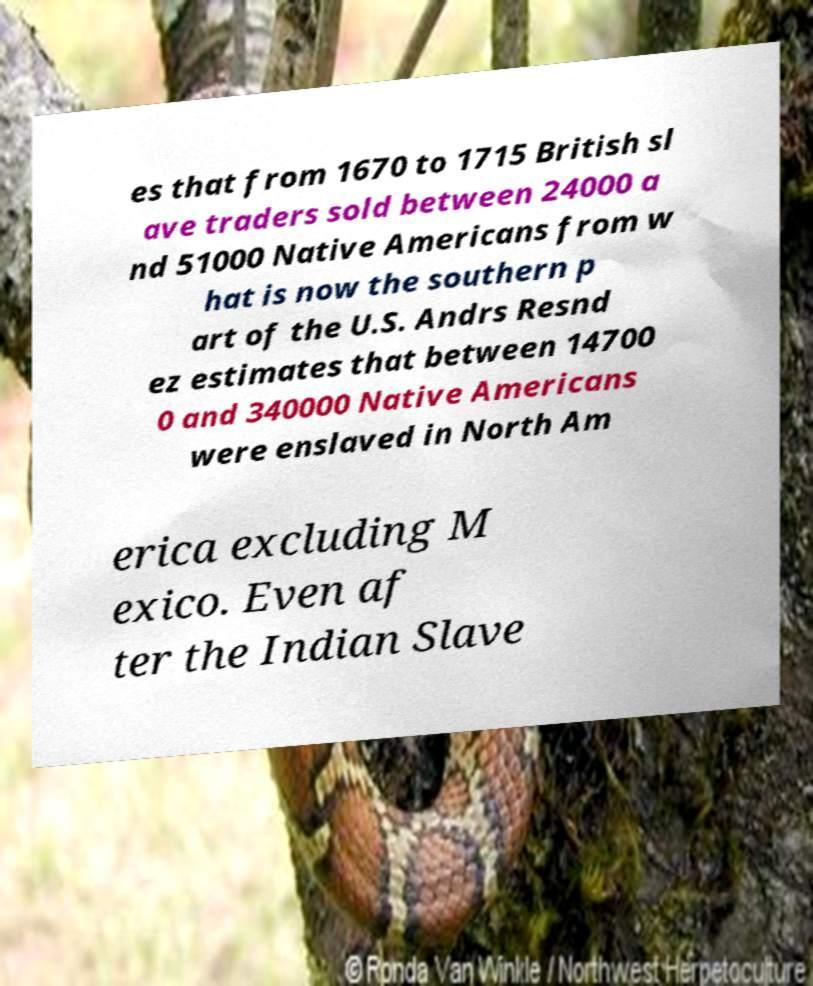Could you extract and type out the text from this image? es that from 1670 to 1715 British sl ave traders sold between 24000 a nd 51000 Native Americans from w hat is now the southern p art of the U.S. Andrs Resnd ez estimates that between 14700 0 and 340000 Native Americans were enslaved in North Am erica excluding M exico. Even af ter the Indian Slave 